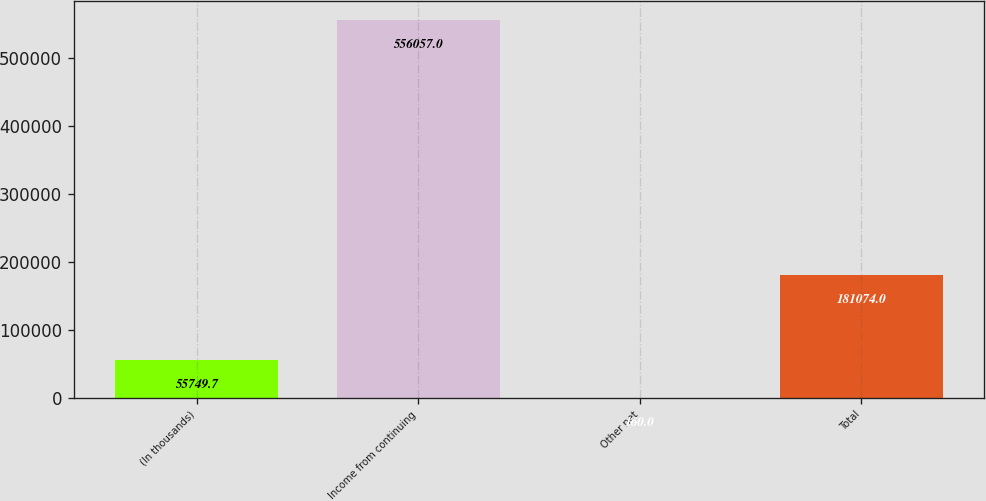<chart> <loc_0><loc_0><loc_500><loc_500><bar_chart><fcel>(In thousands)<fcel>Income from continuing<fcel>Other net<fcel>Total<nl><fcel>55749.7<fcel>556057<fcel>160<fcel>181074<nl></chart> 